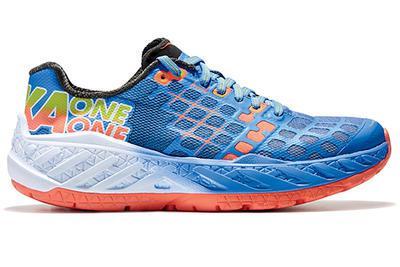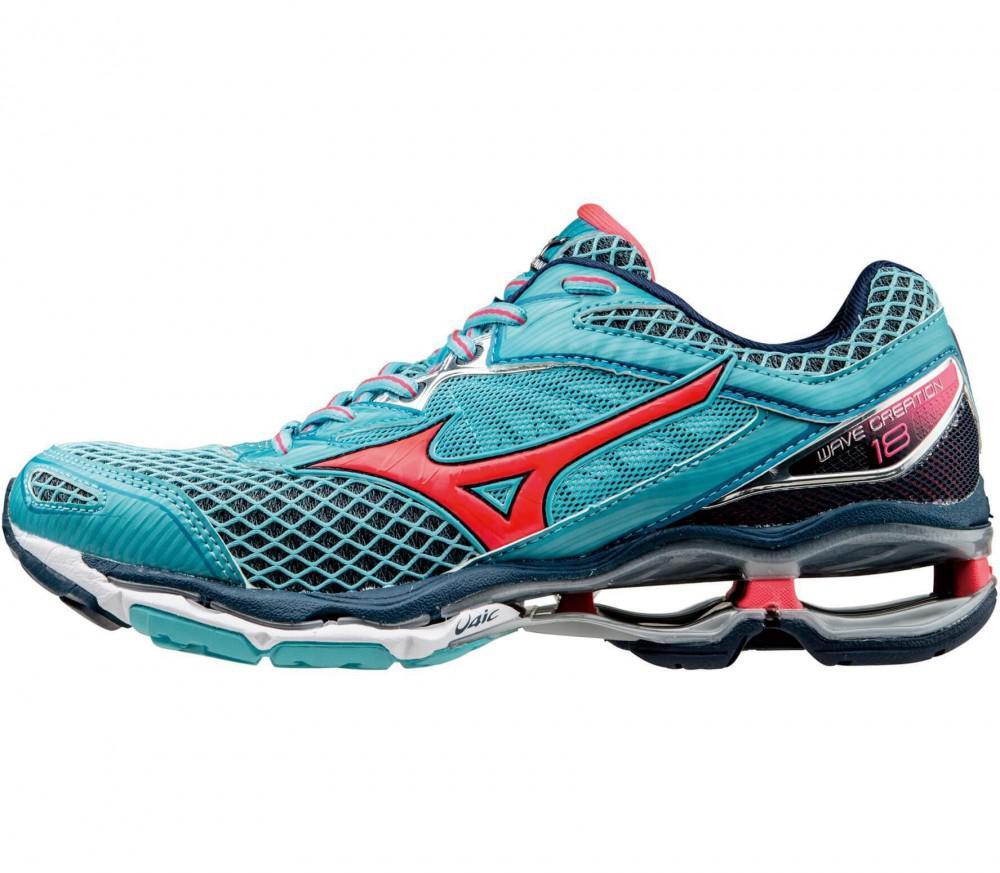The first image is the image on the left, the second image is the image on the right. For the images displayed, is the sentence "there is only one shoe on the right image on a white background" factually correct? Answer yes or no. Yes. 